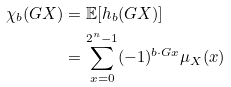Convert formula to latex. <formula><loc_0><loc_0><loc_500><loc_500>\chi _ { b } ( G X ) & = \mathbb { E } [ h _ { b } ( G X ) ] \\ & = \sum _ { x = 0 } ^ { 2 ^ { n } - 1 } ( - 1 ) ^ { b \cdot G x } \mu _ { X } ( x )</formula> 